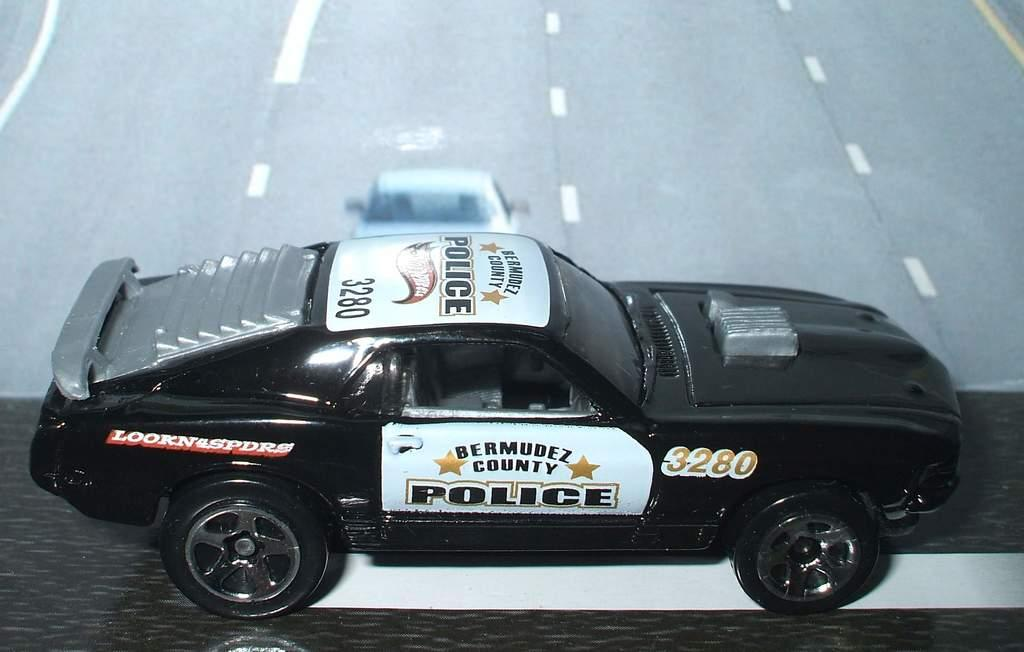What type of vehicles are in the image? There are cars in the image. What colors are the cars in the image? The cars are in white and black colors. What is the setting or location depicted in the image? The image depicts a road. Can you see any mountains in the image? There are no mountains present in the image. What type of utensil is being used by the cars in the image? Cars do not use utensils, so there is no knife or any other utensil present in the image. 